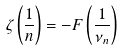<formula> <loc_0><loc_0><loc_500><loc_500>\zeta \left ( \frac { 1 } { n } \right ) = - F \left ( \frac { 1 } { \nu _ { n } } \right )</formula> 